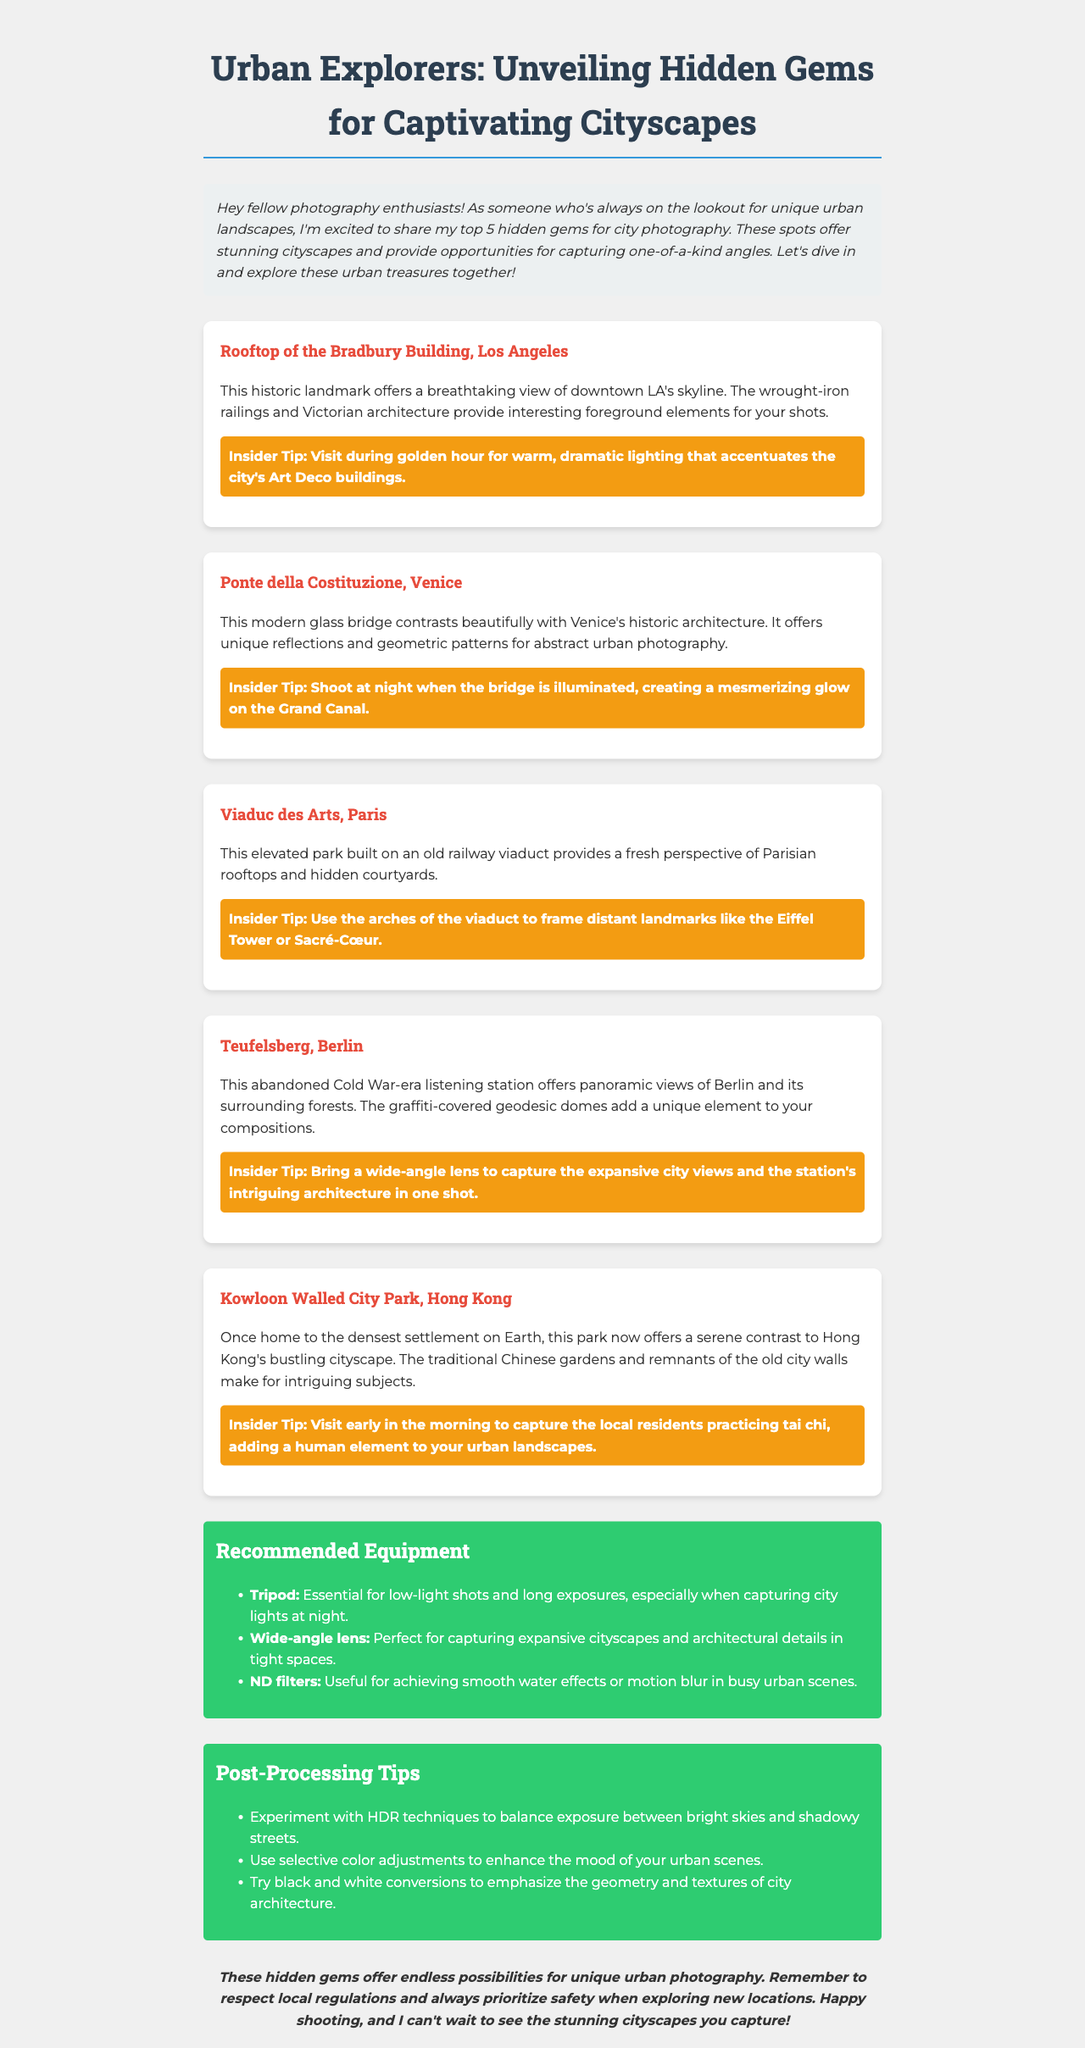What is the title of the newsletter? The title is stated at the top of the document as the main heading.
Answer: Urban Explorers: Unveiling Hidden Gems for Captivating Cityscapes How many hidden gems are listed? The document specifies the number of hidden gems mentioned in the section about them.
Answer: 5 What is the insider tip for the Rooftop of the Bradbury Building? The insider tip is available in the description for the Rooftop of the Bradbury Building.
Answer: Visit during golden hour for warm, dramatic lighting that accentuates the city's Art Deco buildings Which city is the Ponte della Costituzione located in? The city is indicated in the description of the Ponte della Costituzione.
Answer: Venice What equipment is recommended for low-light shots? The equipment recommendation section provides details on essential items for urban photography.
Answer: Tripod What type of lens is suggested for capturing expansive cityscapes? The recommended equipment section outlines specific types of lenses useful for urban photography.
Answer: Wide-angle lens Which post-processing technique is suggested for balancing exposure? The post-processing tips list methods to enhance urban photographs.
Answer: HDR techniques Who is the audience for this newsletter? The introduction gives insights into who the newsletter is aimed at based on the language used.
Answer: Photography enthusiasts 